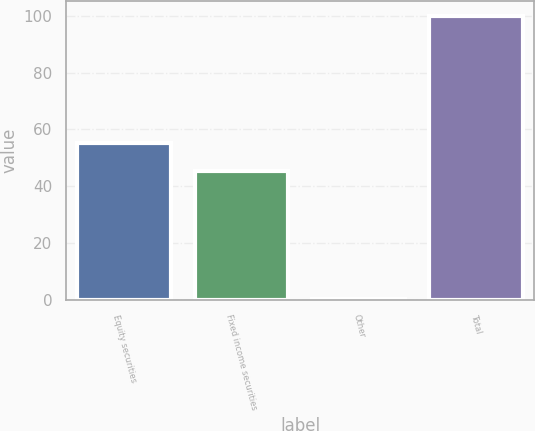<chart> <loc_0><loc_0><loc_500><loc_500><bar_chart><fcel>Equity securities<fcel>Fixed income securities<fcel>Other<fcel>Total<nl><fcel>55.27<fcel>45.3<fcel>0.3<fcel>100<nl></chart> 